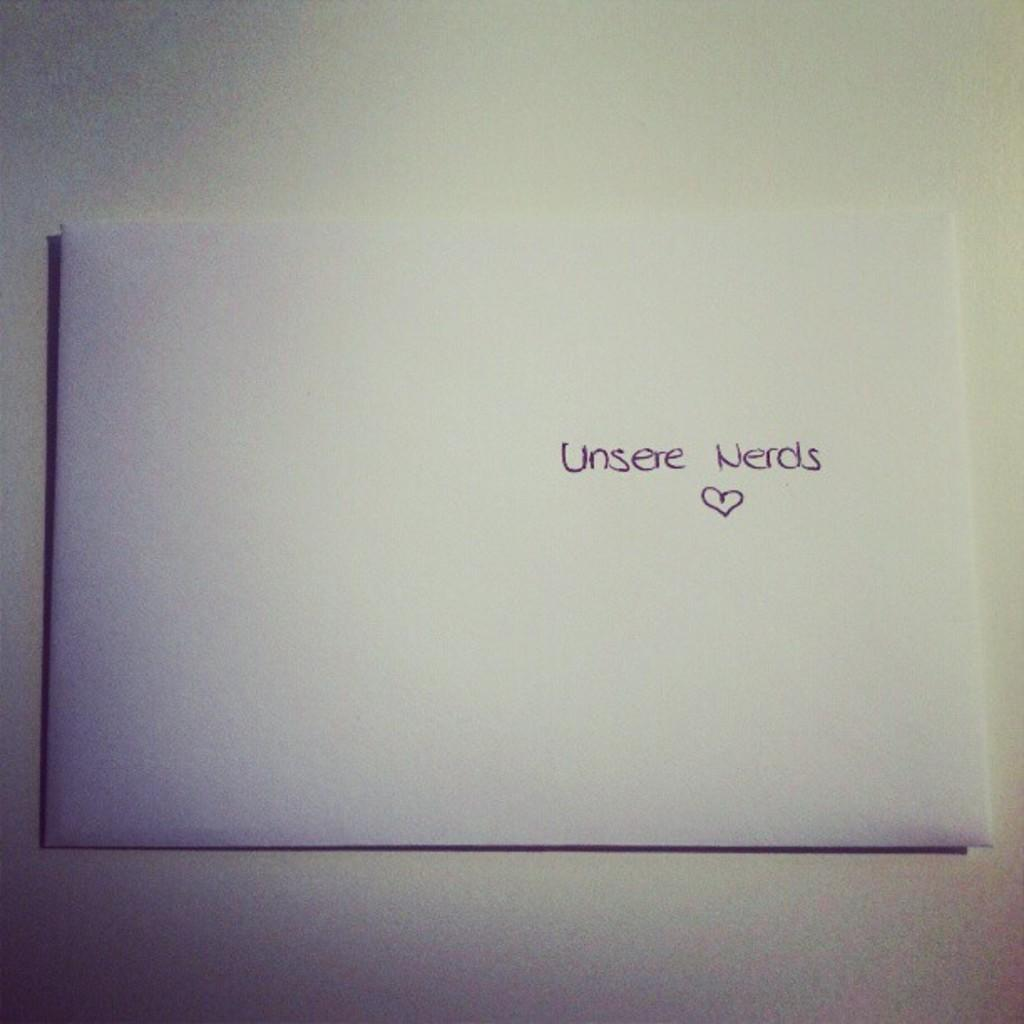<image>
Summarize the visual content of the image. Unsere Nerds and a heart symbol are written on a white envelope. 